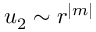Convert formula to latex. <formula><loc_0><loc_0><loc_500><loc_500>u _ { 2 } \sim r ^ { | m | }</formula> 